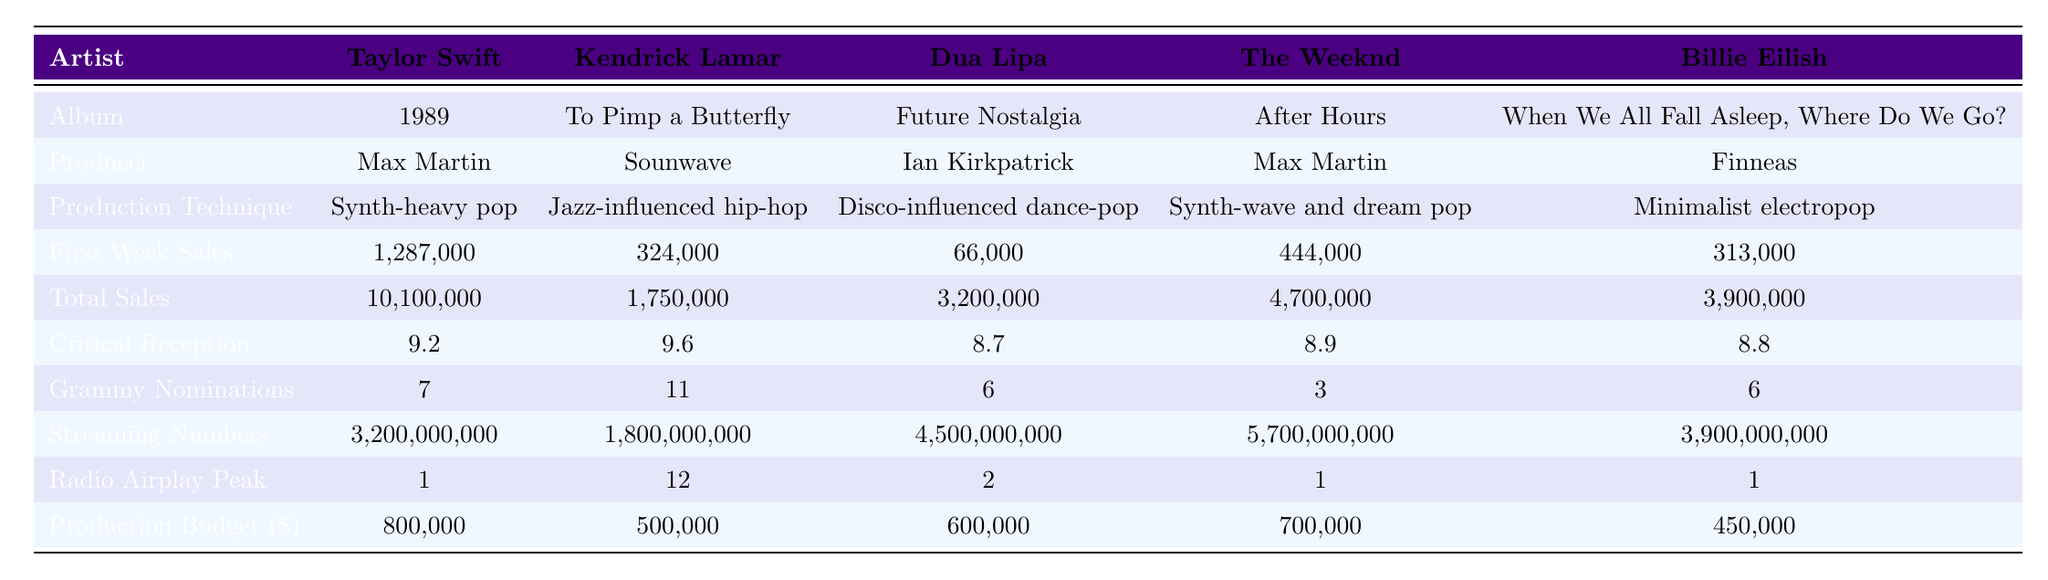What is the production technique used by Billie Eilish? The table lists "Minimalist electropop" as the production technique for Billie Eilish.
Answer: Minimalist electropop Which artist had the highest first week sales? By comparing the first week sales of each artist, Taylor Swift had the highest sales at 1,287,000.
Answer: Taylor Swift What was the total sales for Dua Lipa's album? The total sales for Dua Lipa's album "Future Nostalgia" is listed as 3,200,000.
Answer: 3,200,000 How many Grammy nominations did Kendrick Lamar receive? The table shows that Kendrick Lamar received 11 Grammy nominations.
Answer: 11 Calculate the average critical reception score of all albums. The scores are 9.2, 9.6, 8.7, 8.9, and 8.8. Adding them gives 45.2, and dividing by 5 results in 9.04.
Answer: 9.04 Did Dua Lipa have more total sales than The Weeknd? Dua Lipa's total sales were 3,200,000, while The Weeknd's were 4,700,000. Therefore, Dua Lipa did not have more total sales than The Weeknd.
Answer: No What is the production budget for Taylor Swift's album? The production budget for Taylor Swift's album "1989" is specified as 800,000.
Answer: 800,000 Calculate the difference in first week sales between Taylor Swift and Billie Eilish. Taylor Swift had first week sales of 1,287,000 while Billie Eilish had 313,000. The difference is 1,287,000 - 313,000 = 973,000.
Answer: 973,000 Which artist achieved the highest streaming numbers? The table indicates that The Weeknd achieved the highest streaming numbers with 5,700,000,000.
Answer: The Weeknd How does the first week sales of Kendrick Lamar compare to that of Billie Eilish? Kendrick Lamar sold 324,000 in the first week while Billie Eilish sold 313,000, meaning Kendrick Lamar had higher first week sales.
Answer: Kendrick Lamar had higher sales 